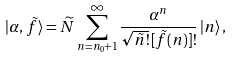Convert formula to latex. <formula><loc_0><loc_0><loc_500><loc_500>| \alpha , \, \tilde { f } \rangle = \widetilde { N } \sum _ { n = n _ { 0 } + 1 } ^ { \infty } \frac { \alpha ^ { n } } { \sqrt { \tilde { n } ! } \, [ \tilde { f } ( n ) ] ! } \, | n \rangle \, ,</formula> 